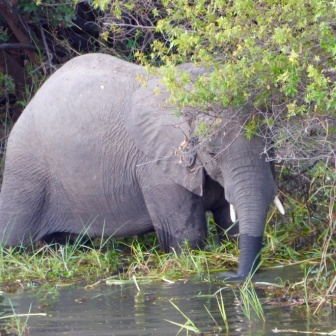Can you describe the main features of this image for me? In this captivating image, an imposing elephant stands with its body partially submerged in a vibrant green water body. The elephant's skin is rugged and gray, marked by the passage of time. Its trunk is immersed in the water, either seeking nourishment or quenching its thirst. Interestingly, the elephant's massive figure is partially obscured by the verdant foliage that envelops the area. The backdrop reveals a dense assembly of trees and shrubs, painting a vivid scene of untamed wilderness. The water teems with life, a myriad of aquatic plants breaking the surface, adding vitality to the tranquil tableau. The photograph beautifully encapsulates a serene moment in the natural habitat. 